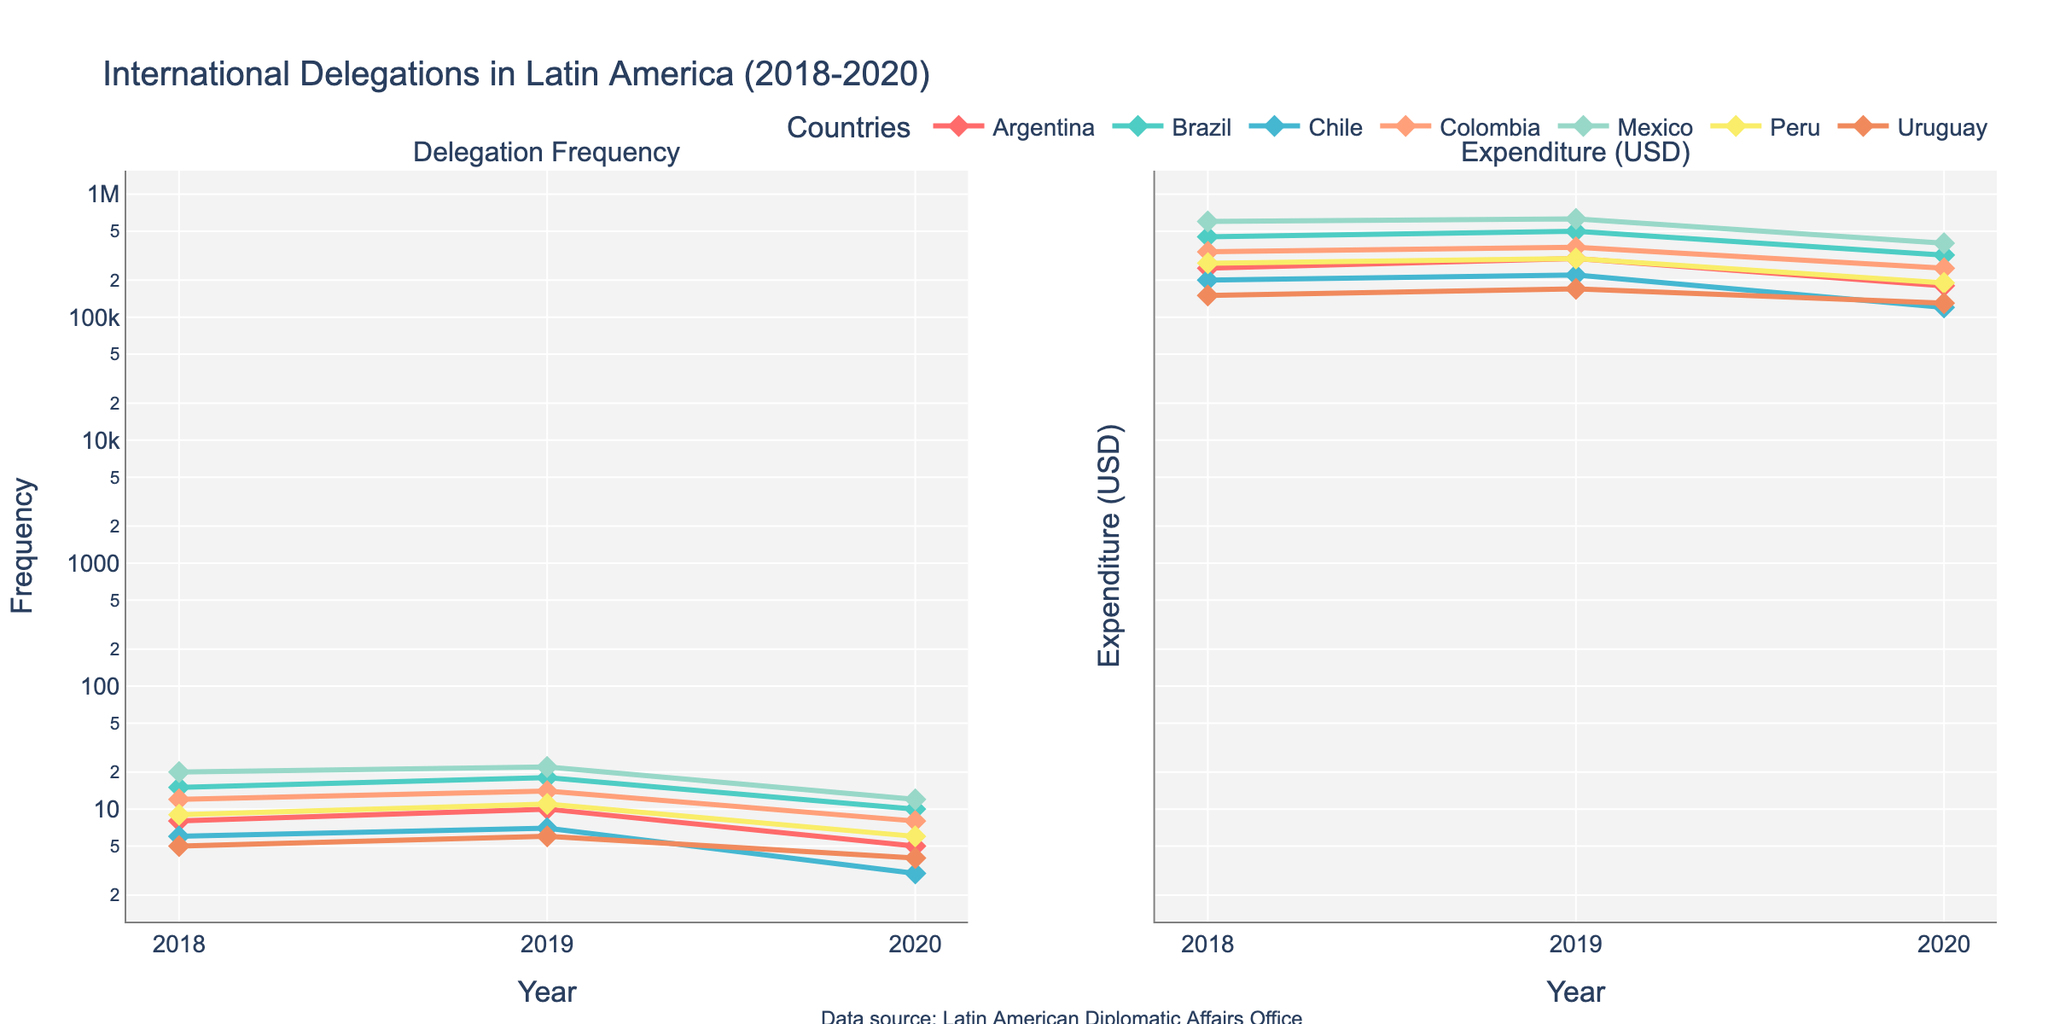What's the title of the figure? The title is easily found at the top of the plot, indicating the subject of the data presented.
Answer: International Delegations in Latin America (2018-2020) What type of axes are used in the subplot? Both y-axes for frequency and expenditure are represented on a logarithmic scale, which is mentioned in the subplot descriptions.
Answer: Logarithmic scale Which country had the highest delegation frequency in 2019? By examining the first subplot and identifying the highest point along the y-axis for 2019, we see that Mexico had the highest frequency with a value of 22.
Answer: Mexico Which country had the lowest expenditure in 2020? Looking at the expenditure subplot for the year 2020, we observe that Uruguay had the lowest expenditure with a value of 130,000 USD.
Answer: Uruguay How did the delegation frequency trend for Argentina change from 2018 to 2020? Following the data points for Argentina in the frequency subplot, the number of delegations went from 8 in 2018 to 10 in 2019, then down to 5 in 2020, showing an initial increase and subsequent decrease.
Answer: Initial increase then decrease Compare Brazil's and Colombia's delegation frequencies in 2020. Which country had a higher frequency? By noting the data points for 2020 in the frequency subplot, Brazil’s delegation frequency was 10 compared to Colombia’s 8.
Answer: Brazil What was the total expenditure for Chile over the three years (2018-2020)? Summing up Chile’s expenditures from the data, we get 200,000 + 220,000 + 120,000 = 540,000 USD.
Answer: 540,000 USD Which country shows a consistent increase in delegation expenditure from 2018 to 2019, but then a decline in 2020? By examining the trends in the expenditure subplot, we see that both Argentina and Brazil fit this pattern.
Answer: Argentina, Brazil On which subplot are the marker symbols described as diamonds used? Both subplots use diamond markers as indicated in the legend and plot lines for each country.
Answer: Both subplots Which two countries had an equal delegation frequency in any year and what was the frequency? Observing the frequency subplot, Argentina and Peru each had a frequency of 6 in 2020.
Answer: Argentina, Peru 